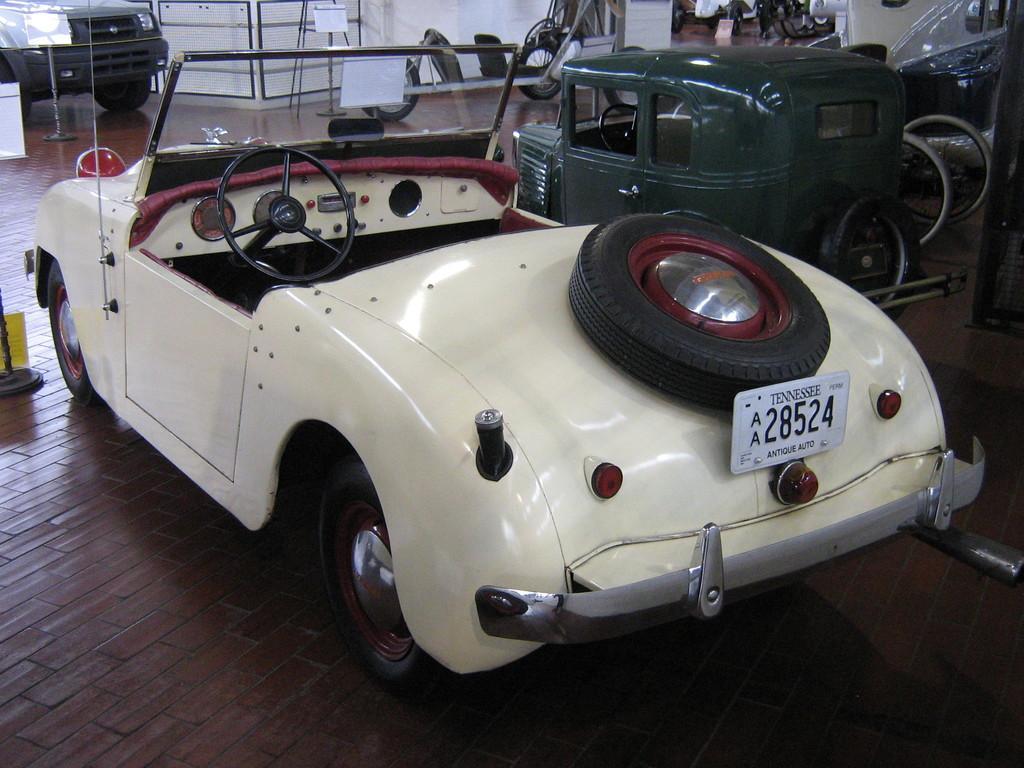Can you describe this image briefly? In this image we can see vehicles. And there is a car. On the car there is a tire and a number plate. In the back there is a wall. Also there are railings. 